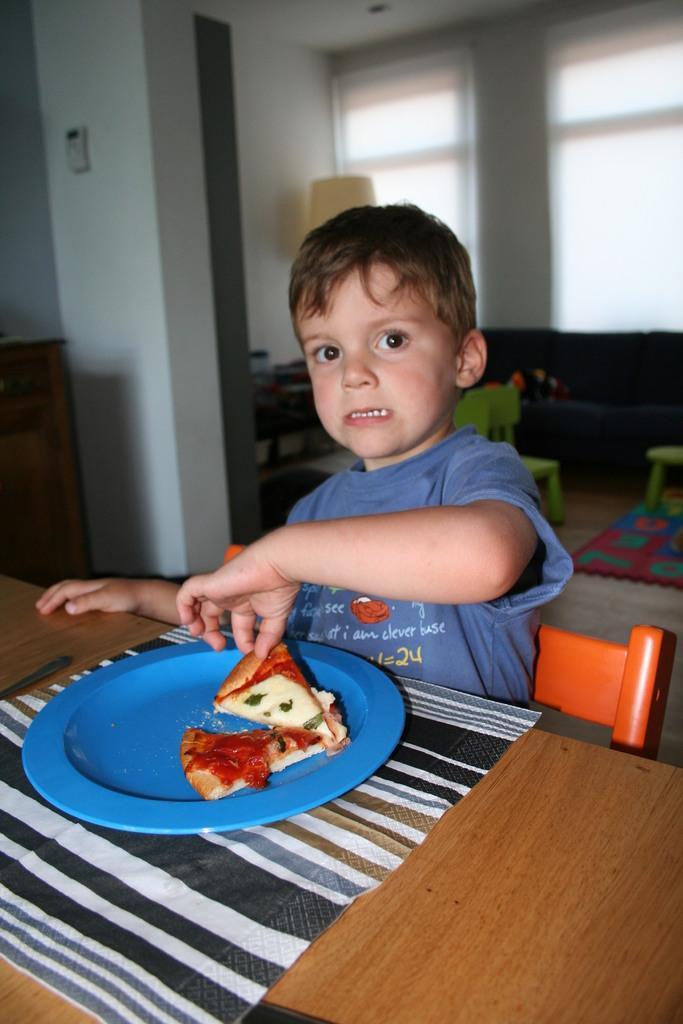Describe this image in one or two sentences. This person sitting on the chair and holding food. We can see plate,mat,food,spoon on the table. On the background we can see glass window,wall,chairs. This is floor. 